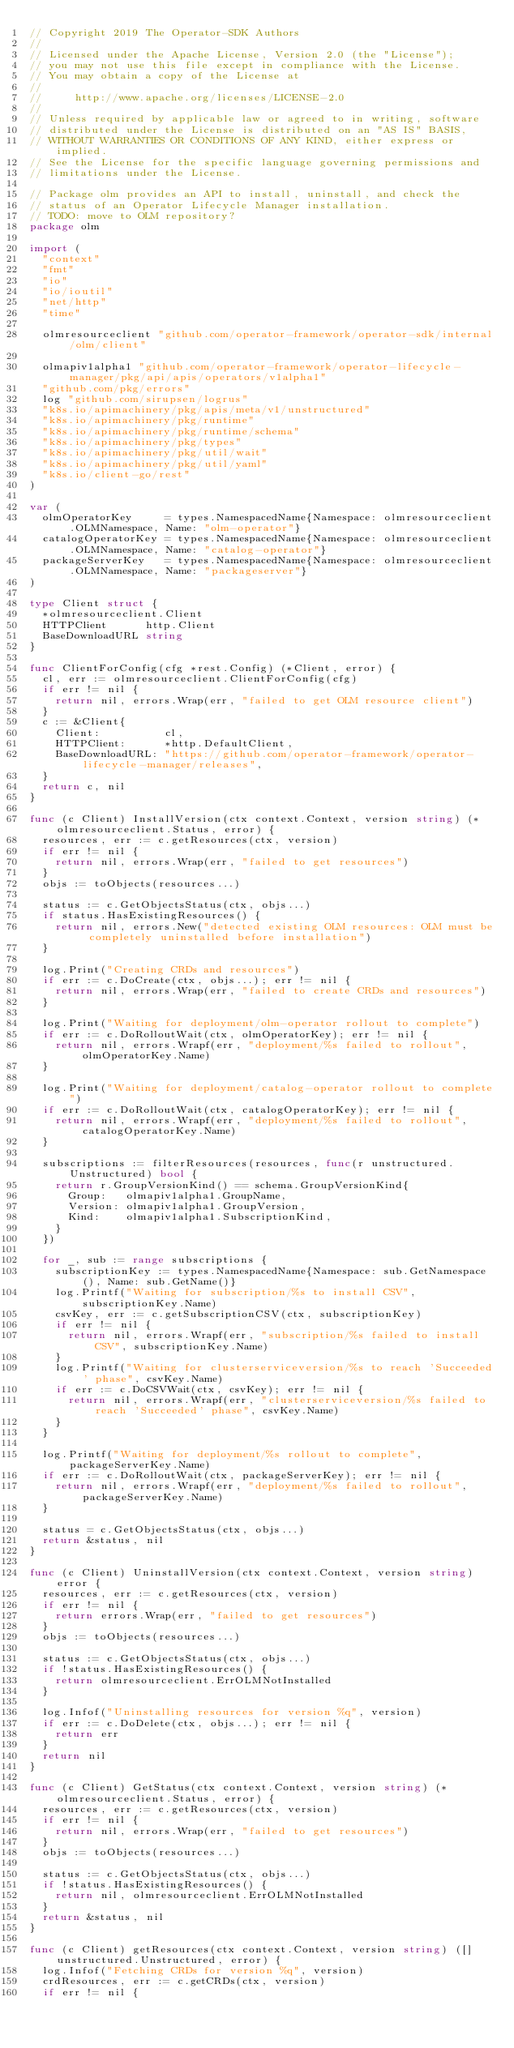<code> <loc_0><loc_0><loc_500><loc_500><_Go_>// Copyright 2019 The Operator-SDK Authors
//
// Licensed under the Apache License, Version 2.0 (the "License");
// you may not use this file except in compliance with the License.
// You may obtain a copy of the License at
//
//     http://www.apache.org/licenses/LICENSE-2.0
//
// Unless required by applicable law or agreed to in writing, software
// distributed under the License is distributed on an "AS IS" BASIS,
// WITHOUT WARRANTIES OR CONDITIONS OF ANY KIND, either express or implied.
// See the License for the specific language governing permissions and
// limitations under the License.

// Package olm provides an API to install, uninstall, and check the
// status of an Operator Lifecycle Manager installation.
// TODO: move to OLM repository?
package olm

import (
	"context"
	"fmt"
	"io"
	"io/ioutil"
	"net/http"
	"time"

	olmresourceclient "github.com/operator-framework/operator-sdk/internal/olm/client"

	olmapiv1alpha1 "github.com/operator-framework/operator-lifecycle-manager/pkg/api/apis/operators/v1alpha1"
	"github.com/pkg/errors"
	log "github.com/sirupsen/logrus"
	"k8s.io/apimachinery/pkg/apis/meta/v1/unstructured"
	"k8s.io/apimachinery/pkg/runtime"
	"k8s.io/apimachinery/pkg/runtime/schema"
	"k8s.io/apimachinery/pkg/types"
	"k8s.io/apimachinery/pkg/util/wait"
	"k8s.io/apimachinery/pkg/util/yaml"
	"k8s.io/client-go/rest"
)

var (
	olmOperatorKey     = types.NamespacedName{Namespace: olmresourceclient.OLMNamespace, Name: "olm-operator"}
	catalogOperatorKey = types.NamespacedName{Namespace: olmresourceclient.OLMNamespace, Name: "catalog-operator"}
	packageServerKey   = types.NamespacedName{Namespace: olmresourceclient.OLMNamespace, Name: "packageserver"}
)

type Client struct {
	*olmresourceclient.Client
	HTTPClient      http.Client
	BaseDownloadURL string
}

func ClientForConfig(cfg *rest.Config) (*Client, error) {
	cl, err := olmresourceclient.ClientForConfig(cfg)
	if err != nil {
		return nil, errors.Wrap(err, "failed to get OLM resource client")
	}
	c := &Client{
		Client:          cl,
		HTTPClient:      *http.DefaultClient,
		BaseDownloadURL: "https://github.com/operator-framework/operator-lifecycle-manager/releases",
	}
	return c, nil
}

func (c Client) InstallVersion(ctx context.Context, version string) (*olmresourceclient.Status, error) {
	resources, err := c.getResources(ctx, version)
	if err != nil {
		return nil, errors.Wrap(err, "failed to get resources")
	}
	objs := toObjects(resources...)

	status := c.GetObjectsStatus(ctx, objs...)
	if status.HasExistingResources() {
		return nil, errors.New("detected existing OLM resources: OLM must be completely uninstalled before installation")
	}

	log.Print("Creating CRDs and resources")
	if err := c.DoCreate(ctx, objs...); err != nil {
		return nil, errors.Wrap(err, "failed to create CRDs and resources")
	}

	log.Print("Waiting for deployment/olm-operator rollout to complete")
	if err := c.DoRolloutWait(ctx, olmOperatorKey); err != nil {
		return nil, errors.Wrapf(err, "deployment/%s failed to rollout", olmOperatorKey.Name)
	}

	log.Print("Waiting for deployment/catalog-operator rollout to complete")
	if err := c.DoRolloutWait(ctx, catalogOperatorKey); err != nil {
		return nil, errors.Wrapf(err, "deployment/%s failed to rollout", catalogOperatorKey.Name)
	}

	subscriptions := filterResources(resources, func(r unstructured.Unstructured) bool {
		return r.GroupVersionKind() == schema.GroupVersionKind{
			Group:   olmapiv1alpha1.GroupName,
			Version: olmapiv1alpha1.GroupVersion,
			Kind:    olmapiv1alpha1.SubscriptionKind,
		}
	})

	for _, sub := range subscriptions {
		subscriptionKey := types.NamespacedName{Namespace: sub.GetNamespace(), Name: sub.GetName()}
		log.Printf("Waiting for subscription/%s to install CSV", subscriptionKey.Name)
		csvKey, err := c.getSubscriptionCSV(ctx, subscriptionKey)
		if err != nil {
			return nil, errors.Wrapf(err, "subscription/%s failed to install CSV", subscriptionKey.Name)
		}
		log.Printf("Waiting for clusterserviceversion/%s to reach 'Succeeded' phase", csvKey.Name)
		if err := c.DoCSVWait(ctx, csvKey); err != nil {
			return nil, errors.Wrapf(err, "clusterserviceversion/%s failed to reach 'Succeeded' phase", csvKey.Name)
		}
	}

	log.Printf("Waiting for deployment/%s rollout to complete", packageServerKey.Name)
	if err := c.DoRolloutWait(ctx, packageServerKey); err != nil {
		return nil, errors.Wrapf(err, "deployment/%s failed to rollout", packageServerKey.Name)
	}

	status = c.GetObjectsStatus(ctx, objs...)
	return &status, nil
}

func (c Client) UninstallVersion(ctx context.Context, version string) error {
	resources, err := c.getResources(ctx, version)
	if err != nil {
		return errors.Wrap(err, "failed to get resources")
	}
	objs := toObjects(resources...)

	status := c.GetObjectsStatus(ctx, objs...)
	if !status.HasExistingResources() {
		return olmresourceclient.ErrOLMNotInstalled
	}

	log.Infof("Uninstalling resources for version %q", version)
	if err := c.DoDelete(ctx, objs...); err != nil {
		return err
	}
	return nil
}

func (c Client) GetStatus(ctx context.Context, version string) (*olmresourceclient.Status, error) {
	resources, err := c.getResources(ctx, version)
	if err != nil {
		return nil, errors.Wrap(err, "failed to get resources")
	}
	objs := toObjects(resources...)

	status := c.GetObjectsStatus(ctx, objs...)
	if !status.HasExistingResources() {
		return nil, olmresourceclient.ErrOLMNotInstalled
	}
	return &status, nil
}

func (c Client) getResources(ctx context.Context, version string) ([]unstructured.Unstructured, error) {
	log.Infof("Fetching CRDs for version %q", version)
	crdResources, err := c.getCRDs(ctx, version)
	if err != nil {</code> 